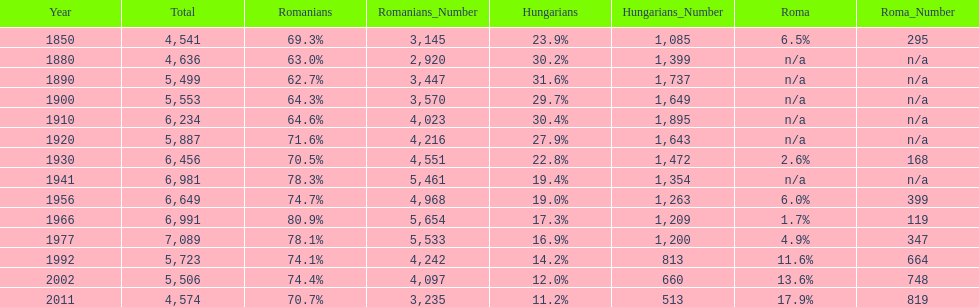What is the number of times the total population was 6,000 or more? 6. 